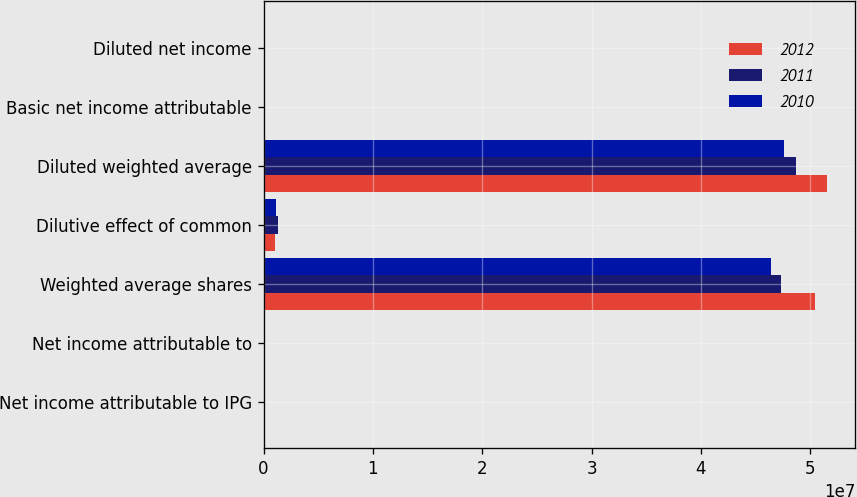Convert chart. <chart><loc_0><loc_0><loc_500><loc_500><stacked_bar_chart><ecel><fcel>Net income attributable to IPG<fcel>Net income attributable to<fcel>Weighted average shares<fcel>Dilutive effect of common<fcel>Diluted weighted average<fcel>Basic net income attributable<fcel>Diluted net income<nl><fcel>2012<fcel>145004<fcel>145497<fcel>5.04771e+07<fcel>1.05932e+06<fcel>5.15364e+07<fcel>2.87<fcel>2.8<nl><fcel>2011<fcel>117759<fcel>117266<fcel>4.73655e+07<fcel>1.31926e+06<fcel>4.86847e+07<fcel>2.48<fcel>2.42<nl><fcel>2010<fcel>53991<fcel>53991<fcel>4.64235e+07<fcel>1.16999e+06<fcel>4.75935e+07<fcel>1.16<fcel>1.13<nl></chart> 